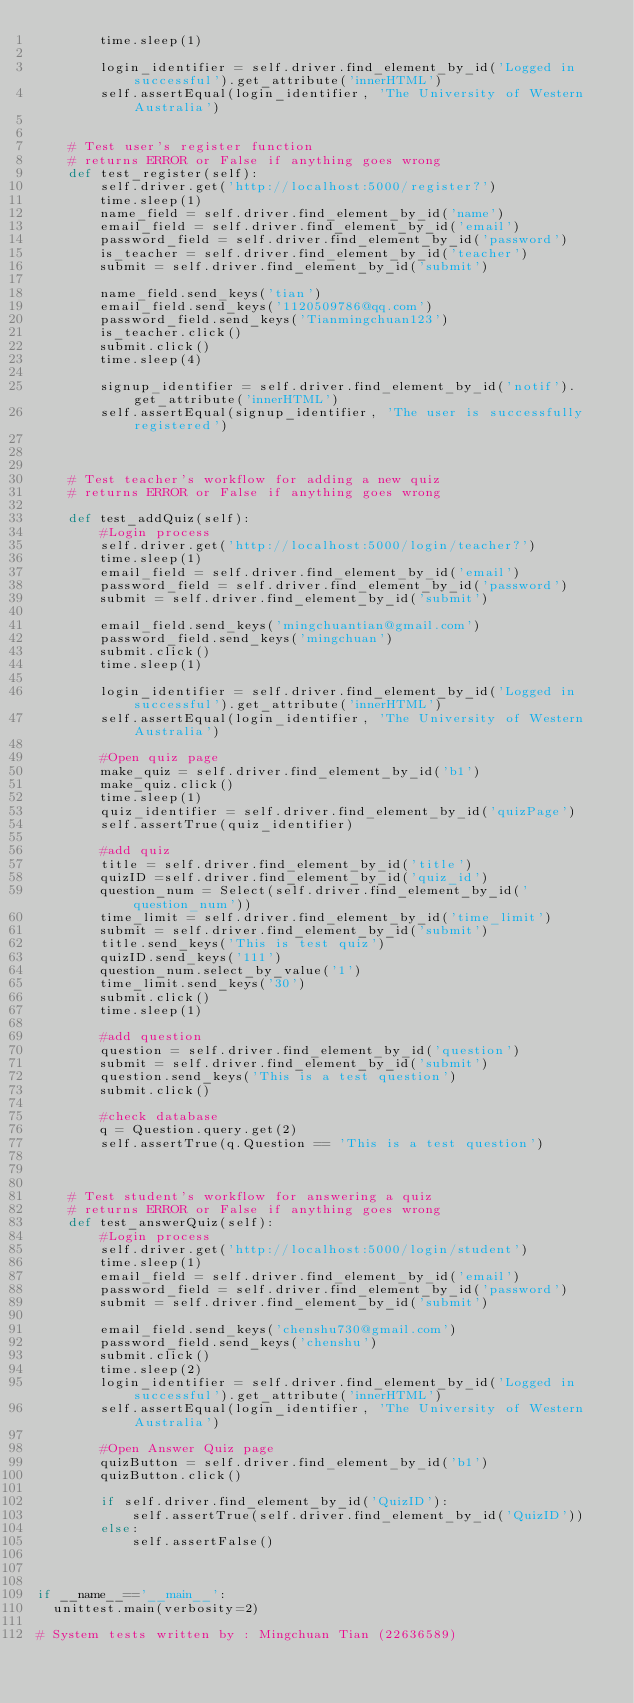Convert code to text. <code><loc_0><loc_0><loc_500><loc_500><_Python_>        time.sleep(1)

        login_identifier = self.driver.find_element_by_id('Logged in successful').get_attribute('innerHTML')
        self.assertEqual(login_identifier, 'The University of Western Australia')
    
    
    # Test user's register function
    # returns ERROR or False if anything goes wrong
    def test_register(self):
        self.driver.get('http://localhost:5000/register?')
        time.sleep(1)
        name_field = self.driver.find_element_by_id('name')
        email_field = self.driver.find_element_by_id('email')
        password_field = self.driver.find_element_by_id('password')
        is_teacher = self.driver.find_element_by_id('teacher')
        submit = self.driver.find_element_by_id('submit')

        name_field.send_keys('tian')
        email_field.send_keys('1120509786@qq.com')
        password_field.send_keys('Tianmingchuan123')
        is_teacher.click()
        submit.click()
        time.sleep(4)

        signup_identifier = self.driver.find_element_by_id('notif').get_attribute('innerHTML')
        self.assertEqual(signup_identifier, 'The user is successfully registered')
    

    
    # Test teacher's workflow for adding a new quiz
    # returns ERROR or False if anything goes wrong
    
    def test_addQuiz(self):
        #Login process
        self.driver.get('http://localhost:5000/login/teacher?')
        time.sleep(1) 
        email_field = self.driver.find_element_by_id('email')
        password_field = self.driver.find_element_by_id('password') 
        submit = self.driver.find_element_by_id('submit')

        email_field.send_keys('mingchuantian@gmail.com')
        password_field.send_keys('mingchuan')
        submit.click()
        time.sleep(1)

        login_identifier = self.driver.find_element_by_id('Logged in successful').get_attribute('innerHTML')
        self.assertEqual(login_identifier, 'The University of Western Australia')

        #Open quiz page
        make_quiz = self.driver.find_element_by_id('b1')
        make_quiz.click()
        time.sleep(1)
        quiz_identifier = self.driver.find_element_by_id('quizPage')
        self.assertTrue(quiz_identifier)

        #add quiz
        title = self.driver.find_element_by_id('title')
        quizID =self.driver.find_element_by_id('quiz_id')
        question_num = Select(self.driver.find_element_by_id('question_num'))
        time_limit = self.driver.find_element_by_id('time_limit')
        submit = self.driver.find_element_by_id('submit')
        title.send_keys('This is test quiz')
        quizID.send_keys('111')
        question_num.select_by_value('1')
        time_limit.send_keys('30')
        submit.click()
        time.sleep(1)

        #add question
        question = self.driver.find_element_by_id('question')
        submit = self.driver.find_element_by_id('submit')
        question.send_keys('This is a test question')
        submit.click()

        #check database
        q = Question.query.get(2)
        self.assertTrue(q.Question == 'This is a test question')
    
        
   
    # Test student's workflow for answering a quiz
    # returns ERROR or False if anything goes wrong 
    def test_answerQuiz(self):
        #Login process
        self.driver.get('http://localhost:5000/login/student')
        time.sleep(1) 
        email_field = self.driver.find_element_by_id('email')
        password_field = self.driver.find_element_by_id('password') 
        submit = self.driver.find_element_by_id('submit')

        email_field.send_keys('chenshu730@gmail.com')
        password_field.send_keys('chenshu')
        submit.click()
        time.sleep(2)
        login_identifier = self.driver.find_element_by_id('Logged in successful').get_attribute('innerHTML')
        self.assertEqual(login_identifier, 'The University of Western Australia')

        #Open Answer Quiz page
        quizButton = self.driver.find_element_by_id('b1')
        quizButton.click()

        if self.driver.find_element_by_id('QuizID'):
            self.assertTrue(self.driver.find_element_by_id('QuizID'))
        else:
            self.assertFalse()



if __name__=='__main__':
  unittest.main(verbosity=2)
    
# System tests written by : Mingchuan Tian (22636589)</code> 